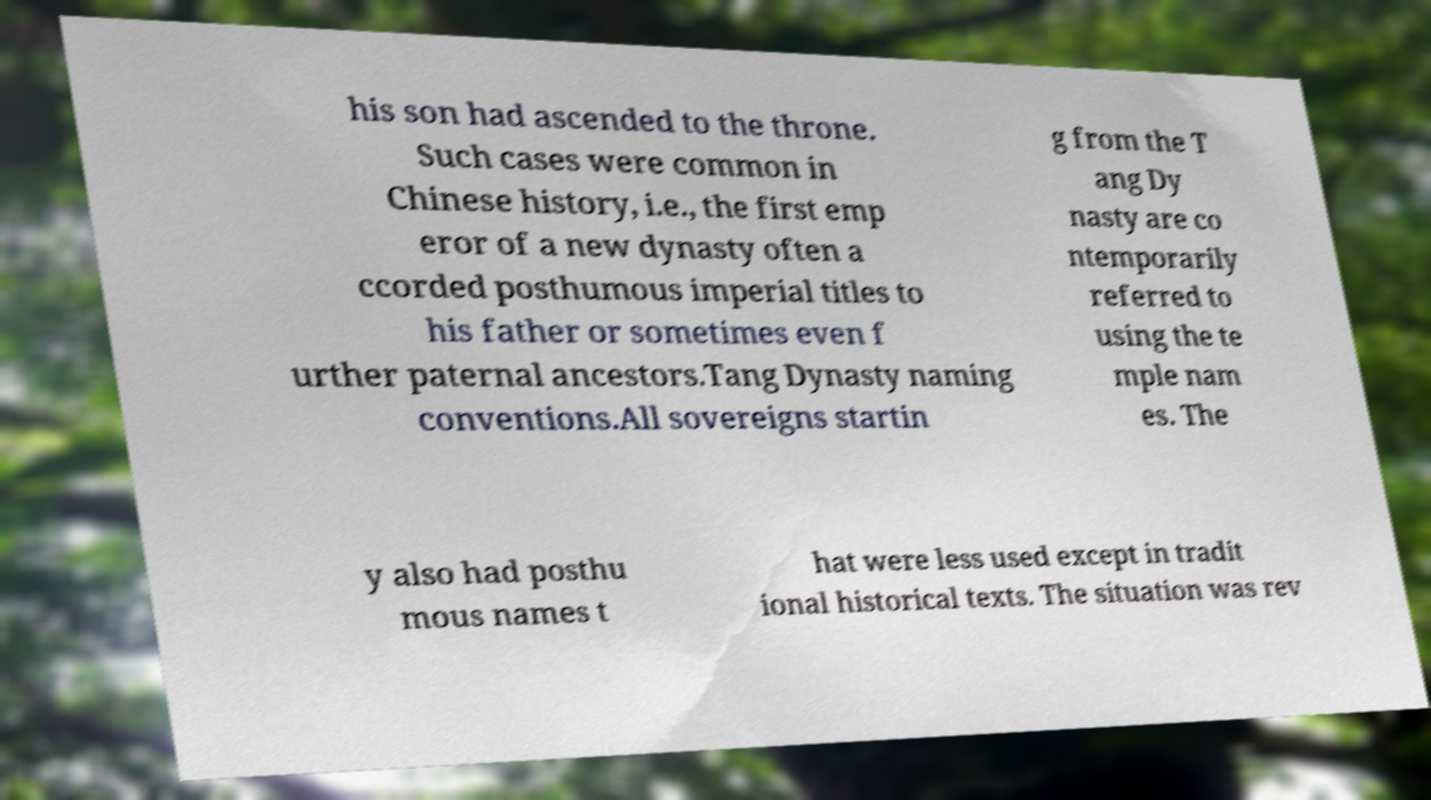Please identify and transcribe the text found in this image. his son had ascended to the throne. Such cases were common in Chinese history, i.e., the first emp eror of a new dynasty often a ccorded posthumous imperial titles to his father or sometimes even f urther paternal ancestors.Tang Dynasty naming conventions.All sovereigns startin g from the T ang Dy nasty are co ntemporarily referred to using the te mple nam es. The y also had posthu mous names t hat were less used except in tradit ional historical texts. The situation was rev 